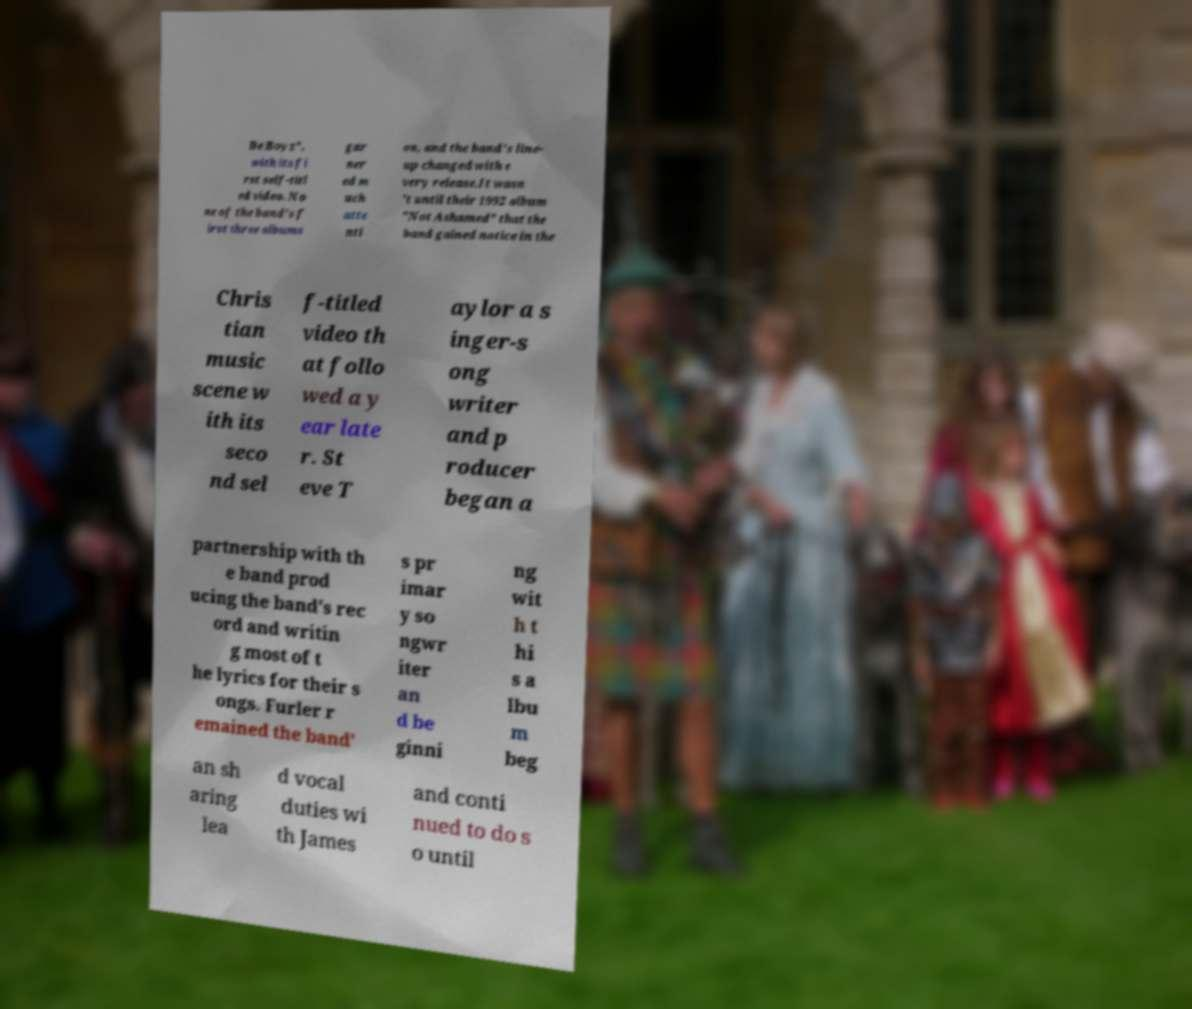I need the written content from this picture converted into text. Can you do that? Be Boyz", with its fi rst self-titl ed video. No ne of the band's f irst three albums gar ner ed m uch atte nti on, and the band's line- up changed with e very release.It wasn 't until their 1992 album "Not Ashamed" that the band gained notice in the Chris tian music scene w ith its seco nd sel f-titled video th at follo wed a y ear late r. St eve T aylor a s inger-s ong writer and p roducer began a partnership with th e band prod ucing the band's rec ord and writin g most of t he lyrics for their s ongs. Furler r emained the band' s pr imar y so ngwr iter an d be ginni ng wit h t hi s a lbu m beg an sh aring lea d vocal duties wi th James and conti nued to do s o until 